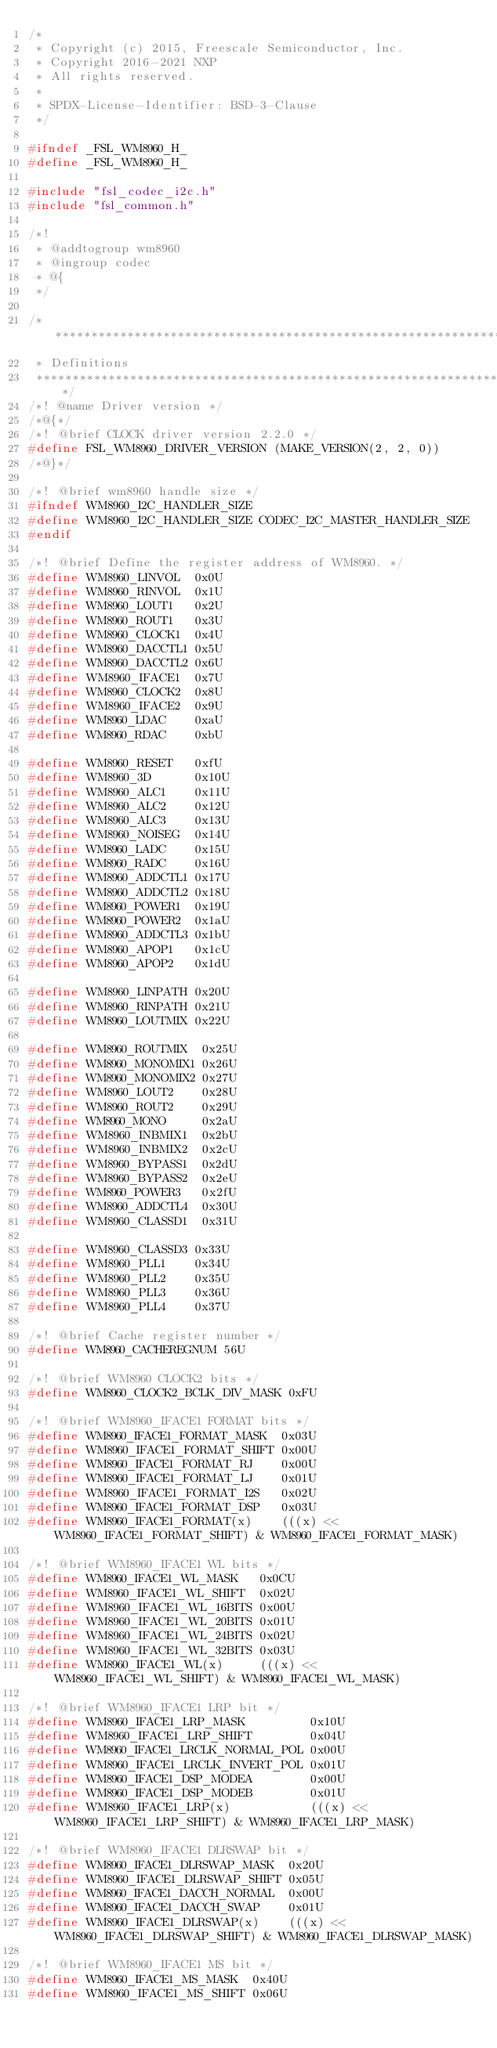<code> <loc_0><loc_0><loc_500><loc_500><_C_>/*
 * Copyright (c) 2015, Freescale Semiconductor, Inc.
 * Copyright 2016-2021 NXP
 * All rights reserved.
 *
 * SPDX-License-Identifier: BSD-3-Clause
 */

#ifndef _FSL_WM8960_H_
#define _FSL_WM8960_H_

#include "fsl_codec_i2c.h"
#include "fsl_common.h"

/*!
 * @addtogroup wm8960
 * @ingroup codec
 * @{
 */

/*******************************************************************************
 * Definitions
 ******************************************************************************/
/*! @name Driver version */
/*@{*/
/*! @brief CLOCK driver version 2.2.0 */
#define FSL_WM8960_DRIVER_VERSION (MAKE_VERSION(2, 2, 0))
/*@}*/

/*! @brief wm8960 handle size */
#ifndef WM8960_I2C_HANDLER_SIZE
#define WM8960_I2C_HANDLER_SIZE CODEC_I2C_MASTER_HANDLER_SIZE
#endif

/*! @brief Define the register address of WM8960. */
#define WM8960_LINVOL  0x0U
#define WM8960_RINVOL  0x1U
#define WM8960_LOUT1   0x2U
#define WM8960_ROUT1   0x3U
#define WM8960_CLOCK1  0x4U
#define WM8960_DACCTL1 0x5U
#define WM8960_DACCTL2 0x6U
#define WM8960_IFACE1  0x7U
#define WM8960_CLOCK2  0x8U
#define WM8960_IFACE2  0x9U
#define WM8960_LDAC    0xaU
#define WM8960_RDAC    0xbU

#define WM8960_RESET   0xfU
#define WM8960_3D      0x10U
#define WM8960_ALC1    0x11U
#define WM8960_ALC2    0x12U
#define WM8960_ALC3    0x13U
#define WM8960_NOISEG  0x14U
#define WM8960_LADC    0x15U
#define WM8960_RADC    0x16U
#define WM8960_ADDCTL1 0x17U
#define WM8960_ADDCTL2 0x18U
#define WM8960_POWER1  0x19U
#define WM8960_POWER2  0x1aU
#define WM8960_ADDCTL3 0x1bU
#define WM8960_APOP1   0x1cU
#define WM8960_APOP2   0x1dU

#define WM8960_LINPATH 0x20U
#define WM8960_RINPATH 0x21U
#define WM8960_LOUTMIX 0x22U

#define WM8960_ROUTMIX  0x25U
#define WM8960_MONOMIX1 0x26U
#define WM8960_MONOMIX2 0x27U
#define WM8960_LOUT2    0x28U
#define WM8960_ROUT2    0x29U
#define WM8960_MONO     0x2aU
#define WM8960_INBMIX1  0x2bU
#define WM8960_INBMIX2  0x2cU
#define WM8960_BYPASS1  0x2dU
#define WM8960_BYPASS2  0x2eU
#define WM8960_POWER3   0x2fU
#define WM8960_ADDCTL4  0x30U
#define WM8960_CLASSD1  0x31U

#define WM8960_CLASSD3 0x33U
#define WM8960_PLL1    0x34U
#define WM8960_PLL2    0x35U
#define WM8960_PLL3    0x36U
#define WM8960_PLL4    0x37U

/*! @brief Cache register number */
#define WM8960_CACHEREGNUM 56U

/*! @brief WM8960 CLOCK2 bits */
#define WM8960_CLOCK2_BCLK_DIV_MASK 0xFU

/*! @brief WM8960_IFACE1 FORMAT bits */
#define WM8960_IFACE1_FORMAT_MASK  0x03U
#define WM8960_IFACE1_FORMAT_SHIFT 0x00U
#define WM8960_IFACE1_FORMAT_RJ    0x00U
#define WM8960_IFACE1_FORMAT_LJ    0x01U
#define WM8960_IFACE1_FORMAT_I2S   0x02U
#define WM8960_IFACE1_FORMAT_DSP   0x03U
#define WM8960_IFACE1_FORMAT(x)    (((x) << WM8960_IFACE1_FORMAT_SHIFT) & WM8960_IFACE1_FORMAT_MASK)

/*! @brief WM8960_IFACE1 WL bits */
#define WM8960_IFACE1_WL_MASK   0x0CU
#define WM8960_IFACE1_WL_SHIFT  0x02U
#define WM8960_IFACE1_WL_16BITS 0x00U
#define WM8960_IFACE1_WL_20BITS 0x01U
#define WM8960_IFACE1_WL_24BITS 0x02U
#define WM8960_IFACE1_WL_32BITS 0x03U
#define WM8960_IFACE1_WL(x)     (((x) << WM8960_IFACE1_WL_SHIFT) & WM8960_IFACE1_WL_MASK)

/*! @brief WM8960_IFACE1 LRP bit */
#define WM8960_IFACE1_LRP_MASK         0x10U
#define WM8960_IFACE1_LRP_SHIFT        0x04U
#define WM8960_IFACE1_LRCLK_NORMAL_POL 0x00U
#define WM8960_IFACE1_LRCLK_INVERT_POL 0x01U
#define WM8960_IFACE1_DSP_MODEA        0x00U
#define WM8960_IFACE1_DSP_MODEB        0x01U
#define WM8960_IFACE1_LRP(x)           (((x) << WM8960_IFACE1_LRP_SHIFT) & WM8960_IFACE1_LRP_MASK)

/*! @brief WM8960_IFACE1 DLRSWAP bit */
#define WM8960_IFACE1_DLRSWAP_MASK  0x20U
#define WM8960_IFACE1_DLRSWAP_SHIFT 0x05U
#define WM8960_IFACE1_DACCH_NORMAL  0x00U
#define WM8960_IFACE1_DACCH_SWAP    0x01U
#define WM8960_IFACE1_DLRSWAP(x)    (((x) << WM8960_IFACE1_DLRSWAP_SHIFT) & WM8960_IFACE1_DLRSWAP_MASK)

/*! @brief WM8960_IFACE1 MS bit */
#define WM8960_IFACE1_MS_MASK  0x40U
#define WM8960_IFACE1_MS_SHIFT 0x06U</code> 